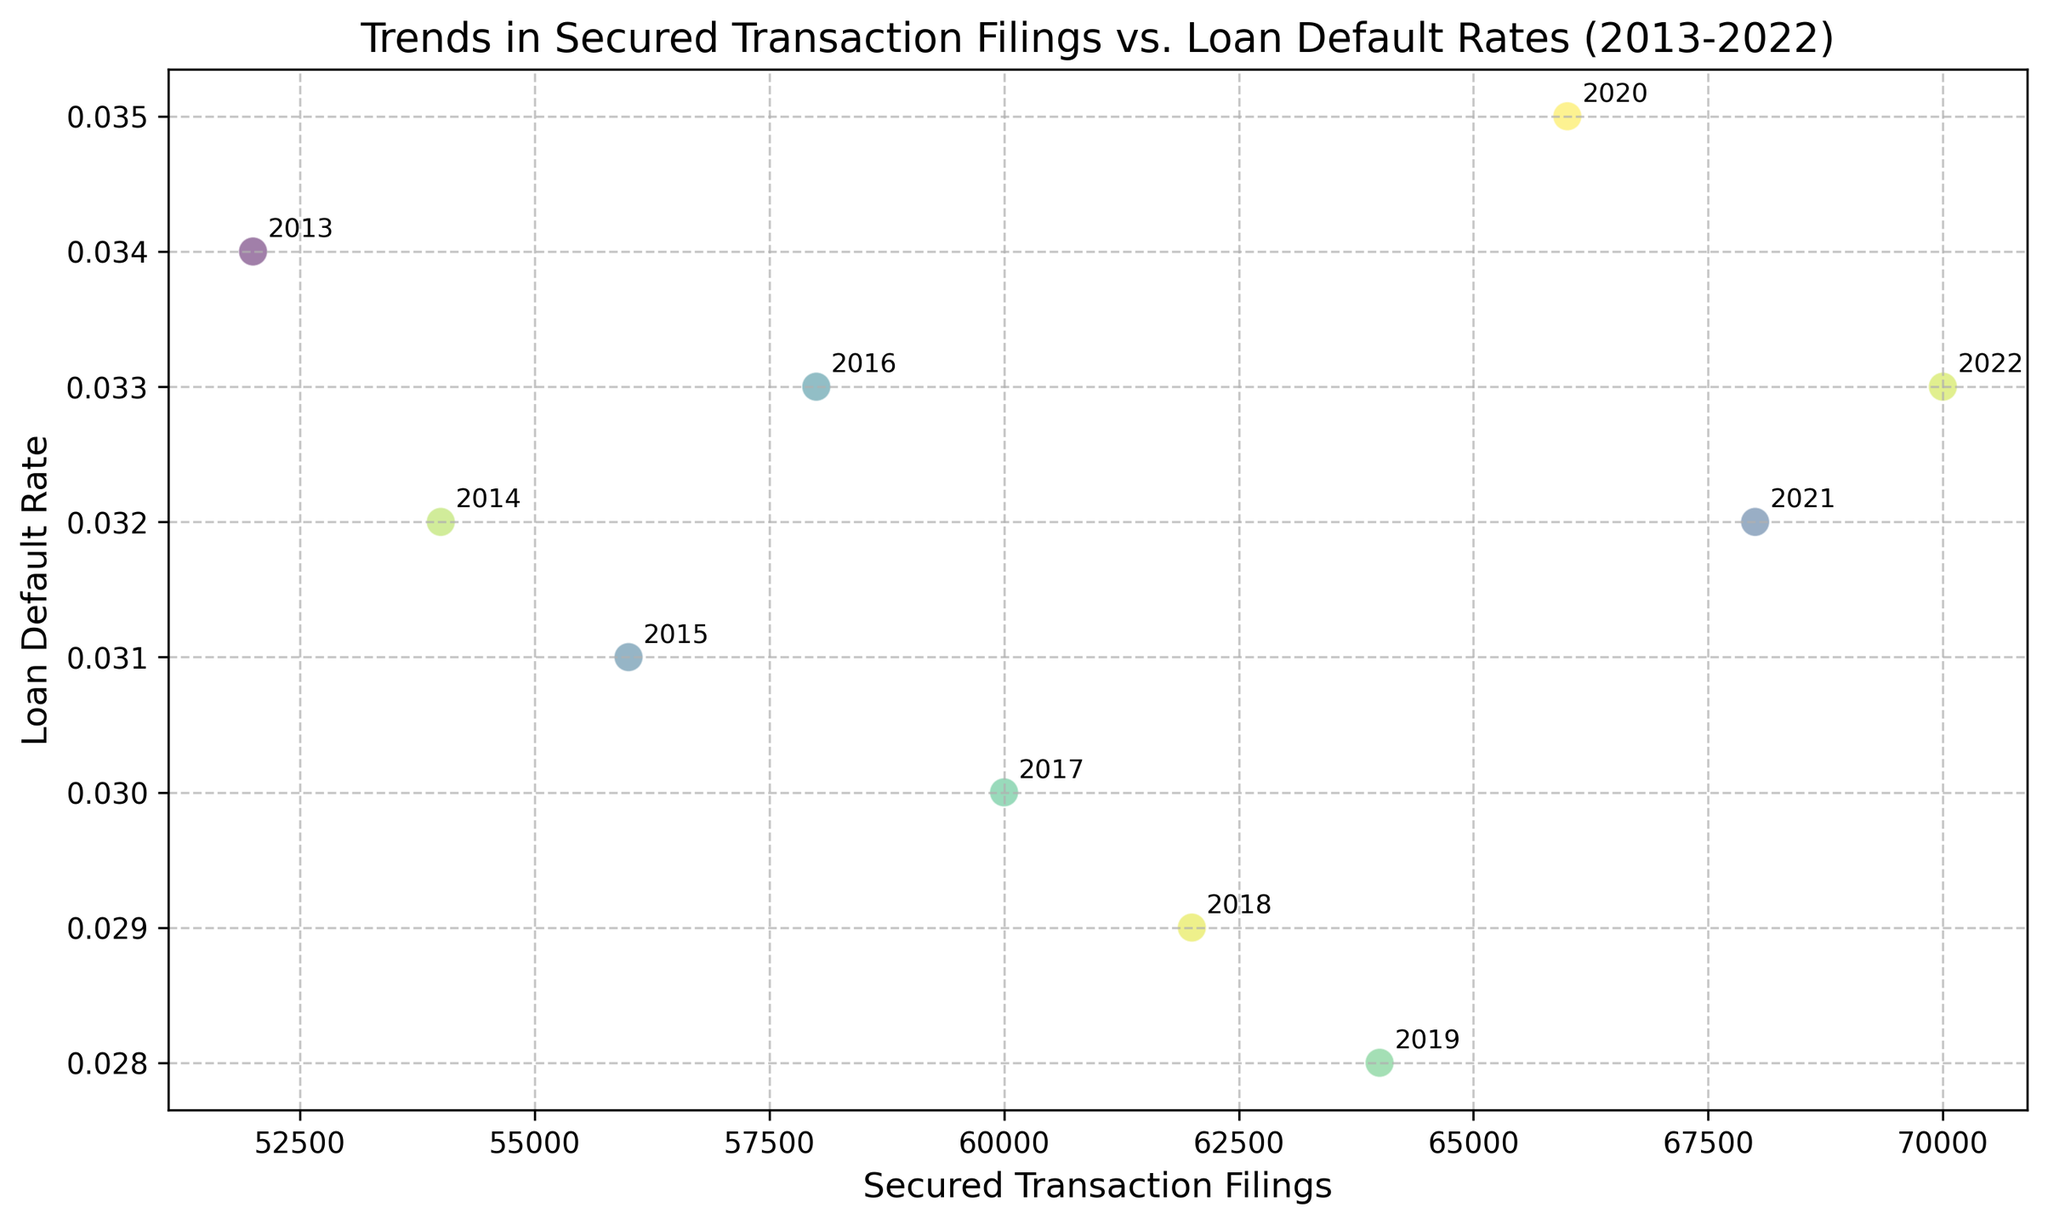What year had the highest number of secured transaction filings? Look for the highest point on the x-axis and note the year annotation. In this case, it is 2022.
Answer: 2022 What is the relationship between secured transaction filings and loan default rates from 2013 to 2022 based on the scatter plot? Observe the general trend of the points on the plot. As secured transaction filings increase, the loan default rate does not show a clear upward or downward trend, indicating a weak correlation.
Answer: Weak correlation Which year had the lowest loan default rate? Look for the lowest point on the y-axis and check the year annotation next to it. In this case, it is 2019.
Answer: 2019 How did the loan default rate change from 2019 to 2020? Compare the y-axis values for 2019 and 2020. The rate increased from 0.028 in 2019 to 0.035 in 2020.
Answer: Increased What is the average loan default rate for the years 2013 to 2022? Sum all the loan default rates and divide by the number of years (0.034 + 0.032 + 0.031 + 0.033 + 0.030 + 0.029 + 0.028 + 0.035 + 0.032 + 0.033)/10 = 0.0317
Answer: 0.0317 How many filings were there in 2018, and what was the loan default rate that year? Identify the point annotated with 2018 and note the corresponding x-axis (62000) and y-axis (0.029) values.
Answer: 62000 filings, 0.029 rate Between which years can we see the most significant drop in the loan default rate? Compare the y-values and note where the biggest vertical drop occurs. Between 2013 (0.034) and 2014 (0.032) is a drop of 0.002, but the biggest drop is between 2017 (0.030) and 2018 (0.029), which is also 0.001 but with a lower baseline overall. Between 2017 and 2018.
Answer: 2017-2018 What is the total sum of secured transaction filings from 2013 to 2022? Add up all the x-axis values (52000 + 54000 + 56000 + 58000 + 60000 + 62000 + 64000 + 66000 + 68000 + 70000) = 610000
Answer: 610000 